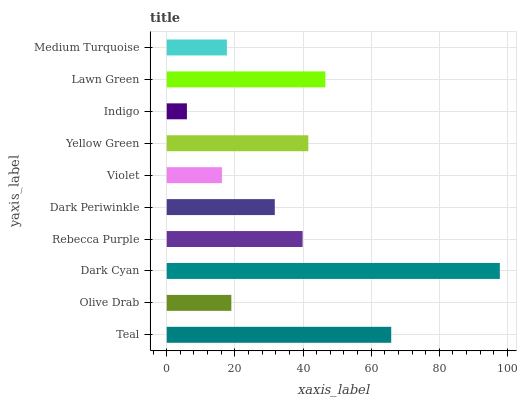Is Indigo the minimum?
Answer yes or no. Yes. Is Dark Cyan the maximum?
Answer yes or no. Yes. Is Olive Drab the minimum?
Answer yes or no. No. Is Olive Drab the maximum?
Answer yes or no. No. Is Teal greater than Olive Drab?
Answer yes or no. Yes. Is Olive Drab less than Teal?
Answer yes or no. Yes. Is Olive Drab greater than Teal?
Answer yes or no. No. Is Teal less than Olive Drab?
Answer yes or no. No. Is Rebecca Purple the high median?
Answer yes or no. Yes. Is Dark Periwinkle the low median?
Answer yes or no. Yes. Is Dark Cyan the high median?
Answer yes or no. No. Is Medium Turquoise the low median?
Answer yes or no. No. 